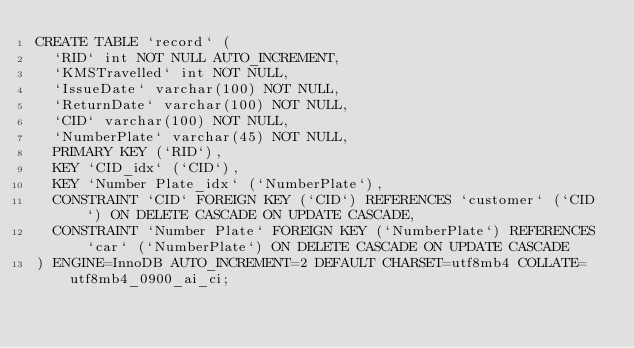Convert code to text. <code><loc_0><loc_0><loc_500><loc_500><_SQL_>CREATE TABLE `record` (
  `RID` int NOT NULL AUTO_INCREMENT,
  `KMSTravelled` int NOT NULL,
  `IssueDate` varchar(100) NOT NULL,
  `ReturnDate` varchar(100) NOT NULL,
  `CID` varchar(100) NOT NULL,
  `NumberPlate` varchar(45) NOT NULL,
  PRIMARY KEY (`RID`),
  KEY `CID_idx` (`CID`),
  KEY `Number Plate_idx` (`NumberPlate`),
  CONSTRAINT `CID` FOREIGN KEY (`CID`) REFERENCES `customer` (`CID`) ON DELETE CASCADE ON UPDATE CASCADE,
  CONSTRAINT `Number Plate` FOREIGN KEY (`NumberPlate`) REFERENCES `car` (`NumberPlate`) ON DELETE CASCADE ON UPDATE CASCADE
) ENGINE=InnoDB AUTO_INCREMENT=2 DEFAULT CHARSET=utf8mb4 COLLATE=utf8mb4_0900_ai_ci;
</code> 